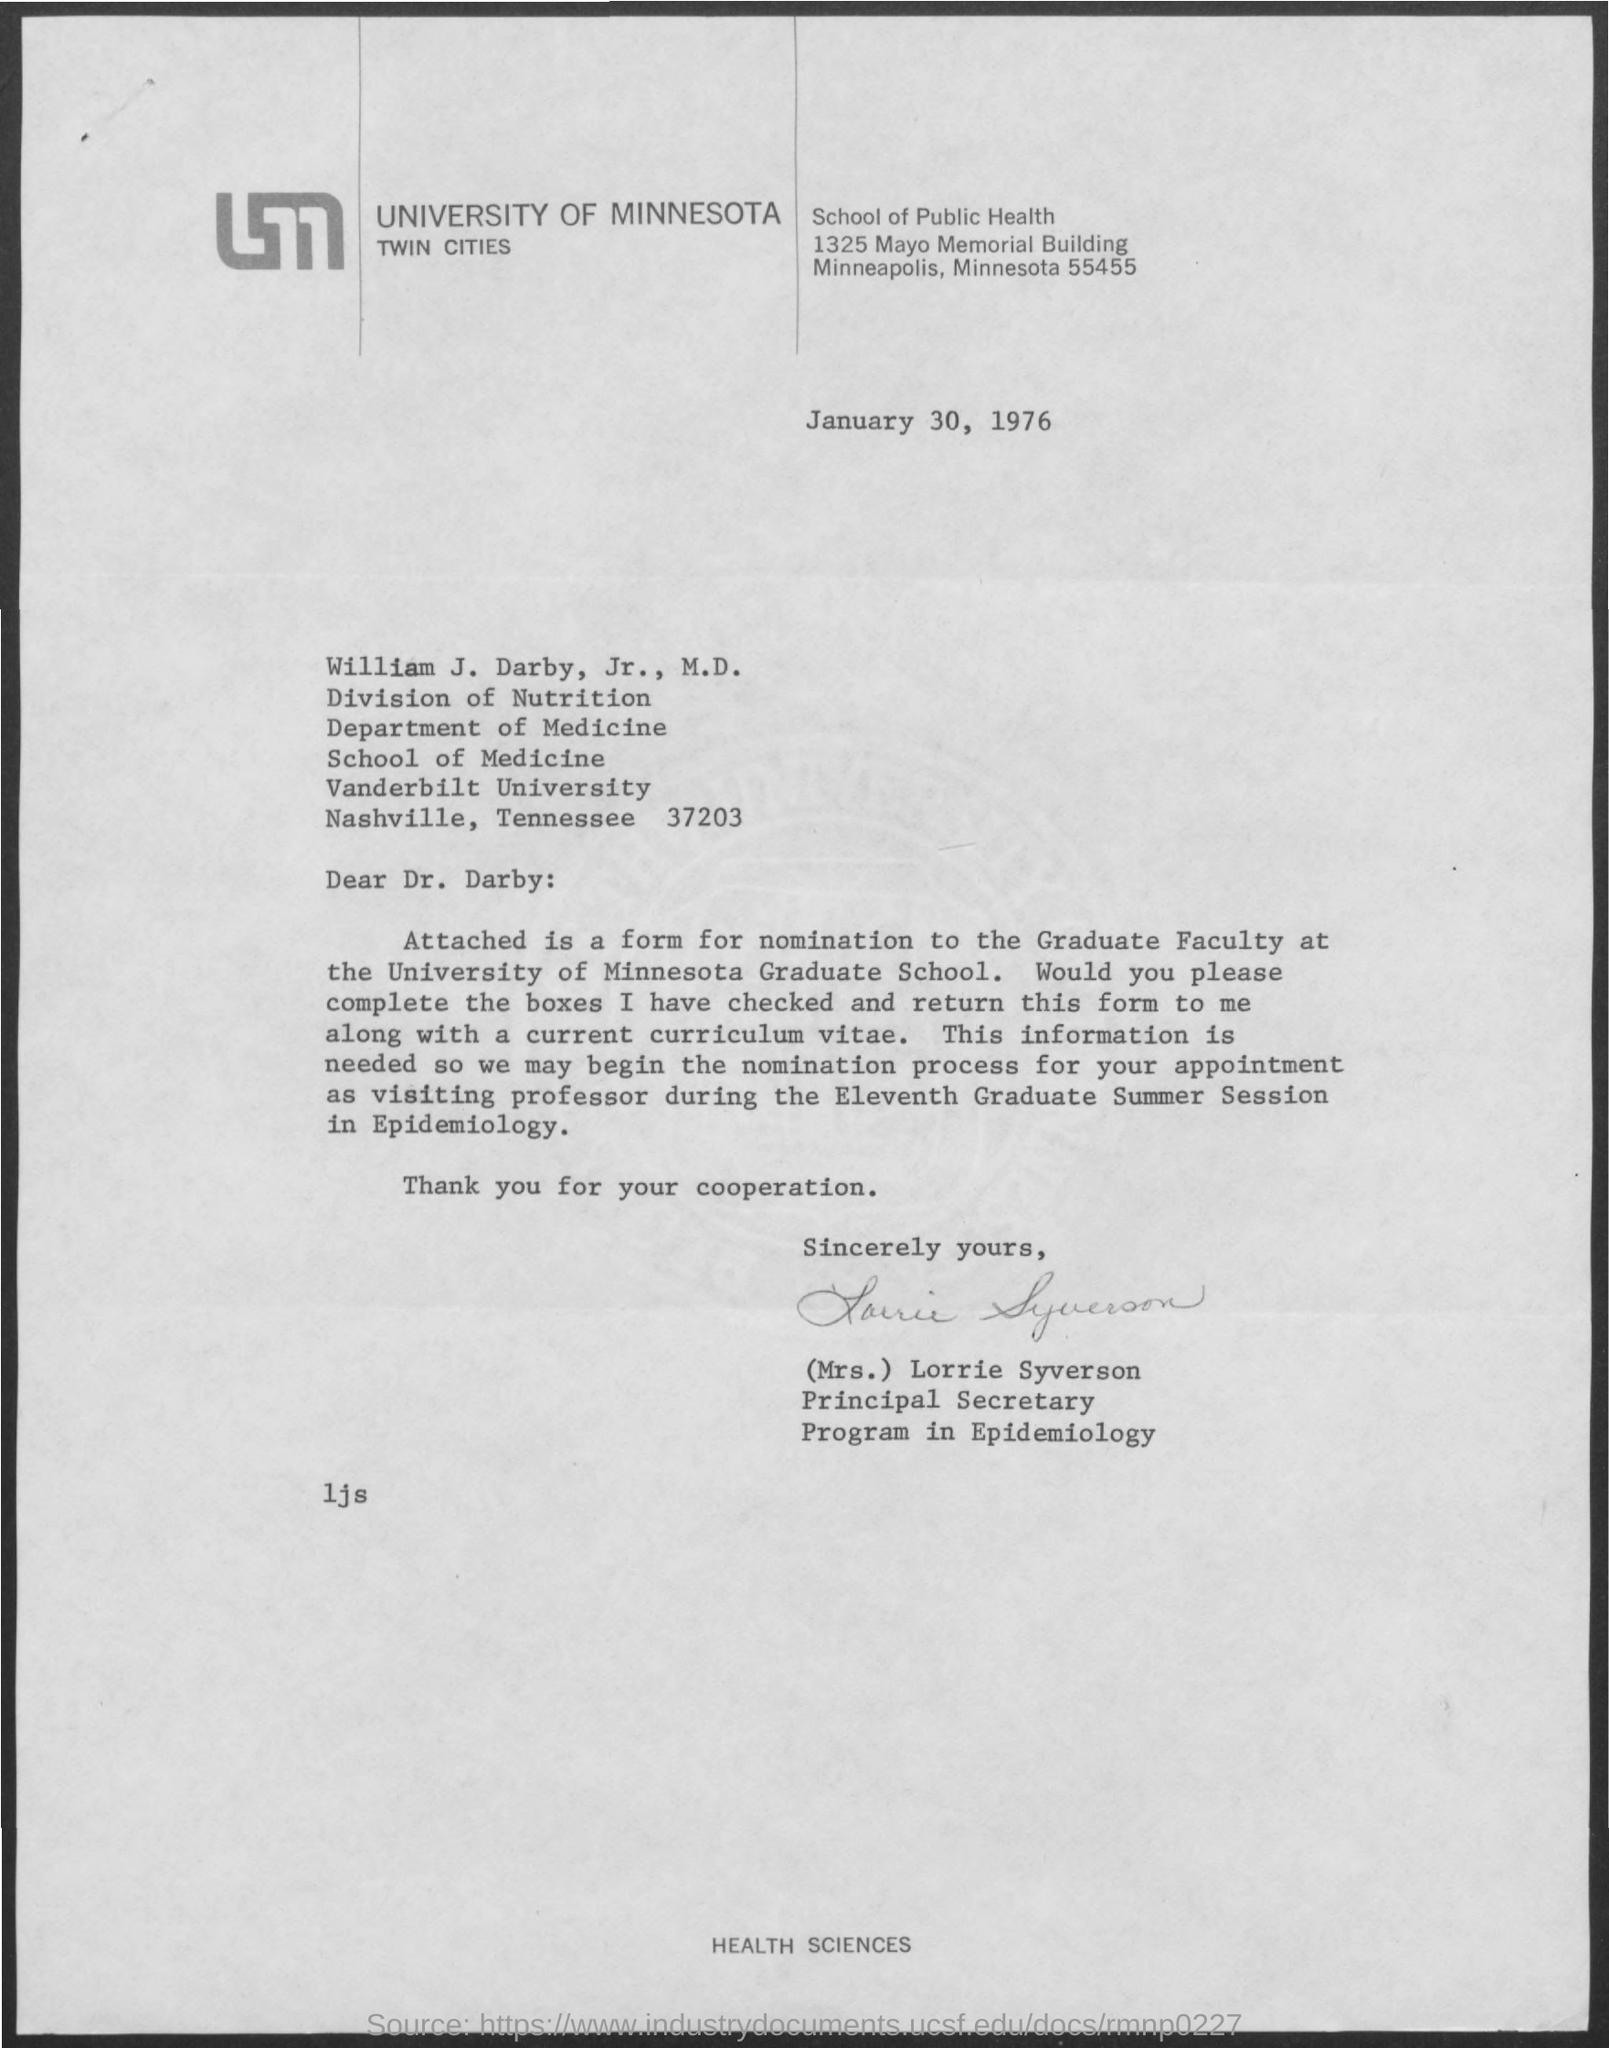Give some essential details in this illustration. The letter head mentions the University of Minnesota. The letter was issued on January 30, 1976. The letter is signed by Mrs. Lorrie Syverson. 